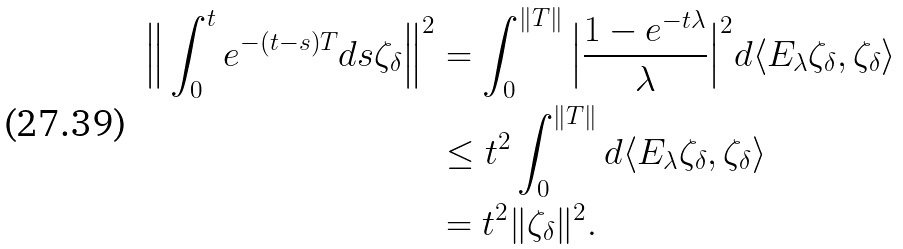<formula> <loc_0><loc_0><loc_500><loc_500>\Big { \| } \int _ { 0 } ^ { t } e ^ { - ( t - s ) T } d s \zeta _ { \delta } \Big { \| } ^ { 2 } & = \int _ { 0 } ^ { \| T \| } \Big { | } \frac { 1 - e ^ { - t \lambda } } { \lambda } \Big { | } ^ { 2 } d \langle E _ { \lambda } \zeta _ { \delta } , \zeta _ { \delta } \rangle \\ & \leq t ^ { 2 } \int _ { 0 } ^ { \| T \| } d \langle E _ { \lambda } \zeta _ { \delta } , \zeta _ { \delta } \rangle \\ & = t ^ { 2 } \| \zeta _ { \delta } \| ^ { 2 } .</formula> 